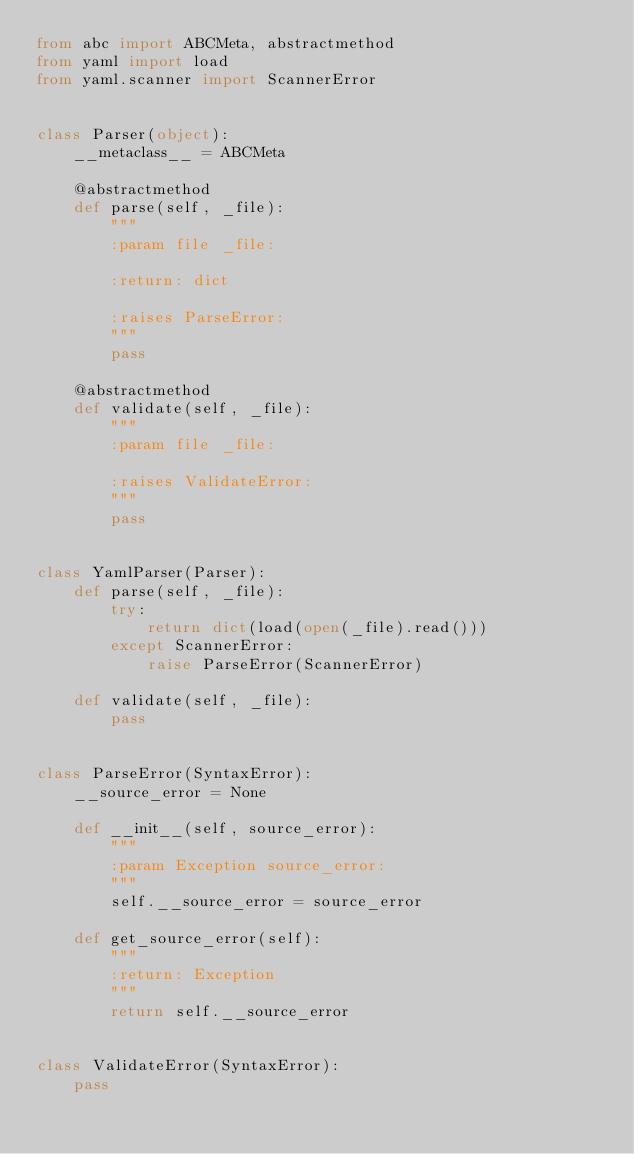Convert code to text. <code><loc_0><loc_0><loc_500><loc_500><_Python_>from abc import ABCMeta, abstractmethod
from yaml import load
from yaml.scanner import ScannerError


class Parser(object):
    __metaclass__ = ABCMeta

    @abstractmethod
    def parse(self, _file):
        """
        :param file _file:

        :return: dict

        :raises ParseError:
        """
        pass

    @abstractmethod
    def validate(self, _file):
        """
        :param file _file:

        :raises ValidateError:
        """
        pass


class YamlParser(Parser):
    def parse(self, _file):
        try:
            return dict(load(open(_file).read()))
        except ScannerError:
            raise ParseError(ScannerError)

    def validate(self, _file):
        pass


class ParseError(SyntaxError):
    __source_error = None

    def __init__(self, source_error):
        """
        :param Exception source_error:
        """
        self.__source_error = source_error

    def get_source_error(self):
        """
        :return: Exception
        """
        return self.__source_error


class ValidateError(SyntaxError):
    pass
</code> 